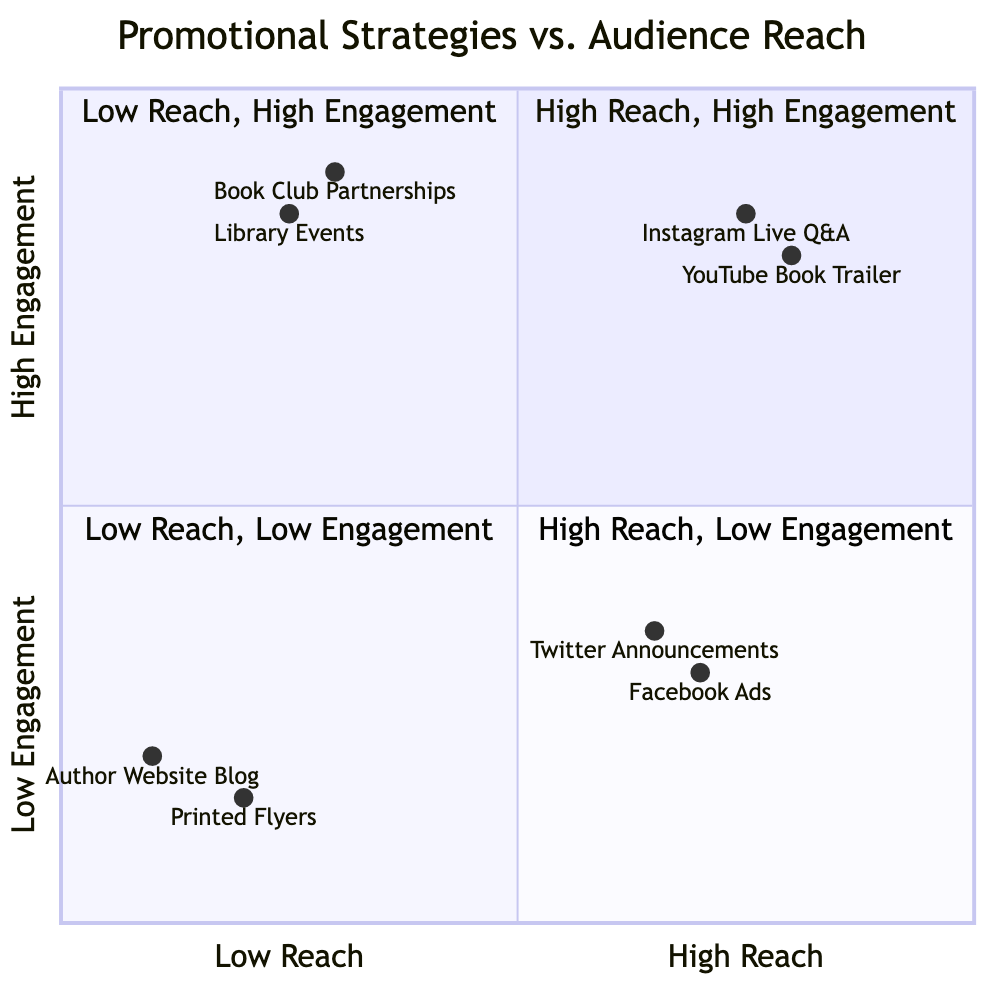What promotional strategy has the highest engagement? To find the promotional strategy with the highest engagement, we look at the y-axis values, which range from low to high engagement (0 to 1). The highest engagement values are 0.9 for Book Club Partnerships, followed closely by Instagram Live Q&A and Library Events with 0.85. Since Book Club Partnerships has the highest at 0.9, it is the answer.
Answer: Book Club Partnerships Which strategy falls under high reach and low engagement? We examine the quadrant 4, which corresponds to high reach and low engagement. The strategies listed in this quadrant are Facebook Ads and Twitter Announcements. Therefore, any of these can be the answer.
Answer: Facebook Ads How many promotional strategies are listed in the high reach, high engagement quadrant? By reviewing quadrant 1, we count the strategies present: Instagram Live Q&A and YouTube Book Trailer, making a total of two strategies.
Answer: 2 What is the engagement score of the YouTube Book Trailer? To find the engagement score, we check the coordinates of the YouTube Book Trailer, which are given as [0.8, 0.8]. The second value in this pair represents the engagement score, thus it is 0.8.
Answer: 0.8 Which quadrant contains the lowest engagement strategies? Looking at quadrant 3, which is designated for low reach and low engagement, we find Printed Flyers and Author Website Blog listed. This quadrant specifically focuses on the lowest engagement strategies.
Answer: Low Reach, Low Engagement What characterizes the strategies in quadrant 2? Quadrant 2 represents low reach and high engagement strategies. The strategies present in this quadrant are Book Club Partnerships and Library Events, characterized by their ability to engage a dedicated audience, albeit with limited reach.
Answer: Low Reach, High Engagement What promotional strategy has the lowest reach? To determine this, we find the strategy with the lowest x-axis value. Examining the values, we see that Author Website Blog has the lowest score at 0.1, indicating it is the promotional strategy with the least reach.
Answer: Author Website Blog How many promotional strategies involve libraries? Analyzing the diagram, we see Library Events fall into quadrant 2, which focuses on low reach but high engagement strategies involving libraries. Since there is only one strategy specifically mentioning libraries, we conclude that there is just one.
Answer: 1 What is the engagement score of the Printed Flyers? The engagement score for Printed Flyers can be found in quadrant 3. The coordinates for Printed Flyers are [0.2, 0.15], so the engagement score, which is the second value, is 0.15.
Answer: 0.15 